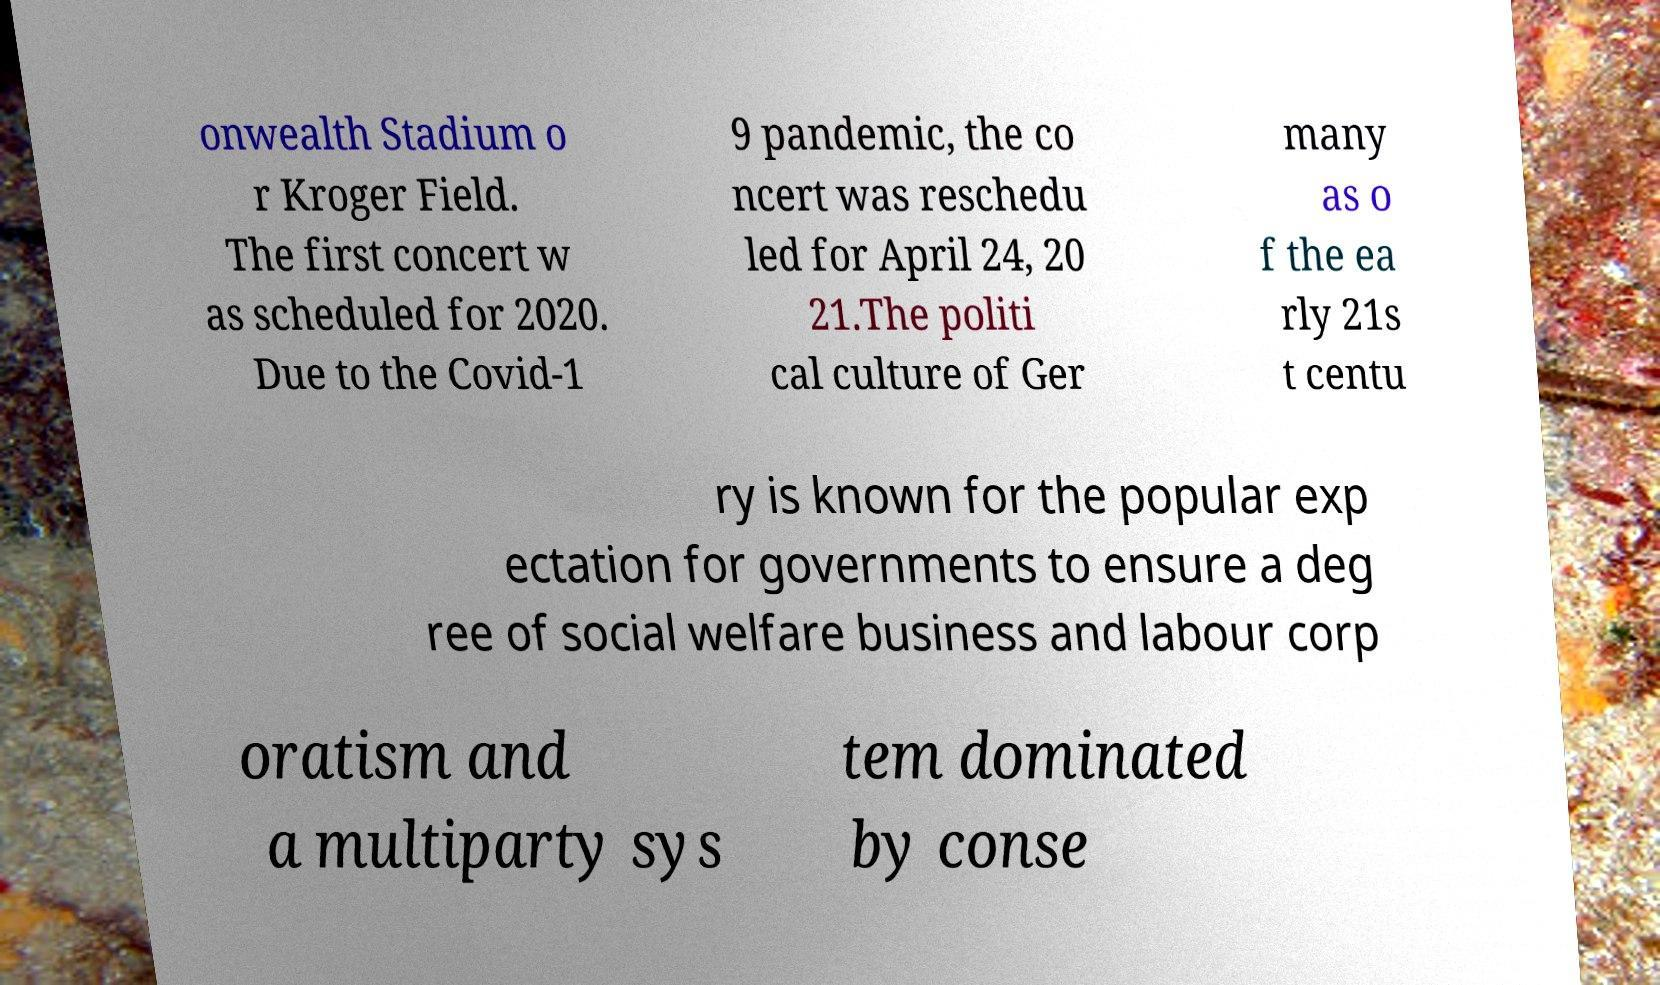Could you extract and type out the text from this image? onwealth Stadium o r Kroger Field. The first concert w as scheduled for 2020. Due to the Covid-1 9 pandemic, the co ncert was reschedu led for April 24, 20 21.The politi cal culture of Ger many as o f the ea rly 21s t centu ry is known for the popular exp ectation for governments to ensure a deg ree of social welfare business and labour corp oratism and a multiparty sys tem dominated by conse 